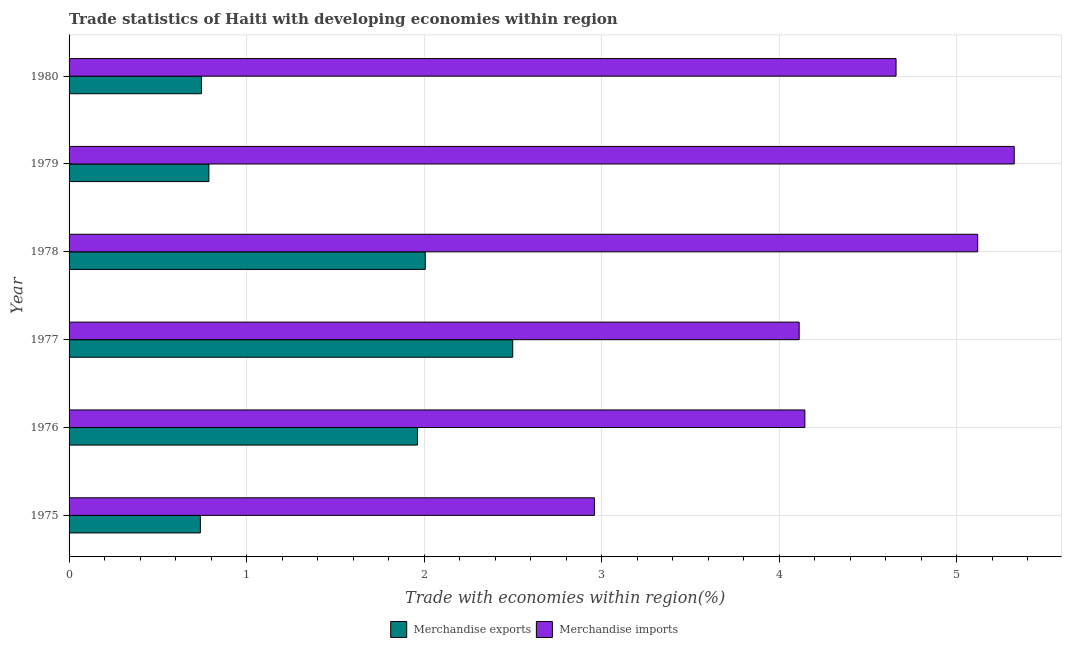How many bars are there on the 6th tick from the top?
Offer a terse response. 2. How many bars are there on the 5th tick from the bottom?
Ensure brevity in your answer.  2. What is the merchandise exports in 1975?
Offer a terse response. 0.74. Across all years, what is the maximum merchandise exports?
Give a very brief answer. 2.5. Across all years, what is the minimum merchandise exports?
Offer a terse response. 0.74. In which year was the merchandise imports maximum?
Give a very brief answer. 1979. In which year was the merchandise exports minimum?
Give a very brief answer. 1975. What is the total merchandise exports in the graph?
Provide a succinct answer. 8.74. What is the difference between the merchandise exports in 1976 and that in 1977?
Ensure brevity in your answer.  -0.54. What is the difference between the merchandise exports in 1979 and the merchandise imports in 1977?
Offer a terse response. -3.32. What is the average merchandise imports per year?
Offer a very short reply. 4.38. In the year 1977, what is the difference between the merchandise exports and merchandise imports?
Your response must be concise. -1.61. In how many years, is the merchandise imports greater than 1.6 %?
Your response must be concise. 6. What is the ratio of the merchandise imports in 1976 to that in 1978?
Offer a very short reply. 0.81. Is the difference between the merchandise exports in 1975 and 1976 greater than the difference between the merchandise imports in 1975 and 1976?
Your answer should be very brief. No. What is the difference between the highest and the second highest merchandise imports?
Ensure brevity in your answer.  0.21. What is the difference between the highest and the lowest merchandise imports?
Offer a very short reply. 2.36. Is the sum of the merchandise exports in 1976 and 1977 greater than the maximum merchandise imports across all years?
Give a very brief answer. No. What does the 1st bar from the bottom in 1975 represents?
Ensure brevity in your answer.  Merchandise exports. How many bars are there?
Provide a succinct answer. 12. Are all the bars in the graph horizontal?
Your answer should be very brief. Yes. What is the difference between two consecutive major ticks on the X-axis?
Provide a short and direct response. 1. Are the values on the major ticks of X-axis written in scientific E-notation?
Offer a very short reply. No. Does the graph contain any zero values?
Give a very brief answer. No. How many legend labels are there?
Provide a succinct answer. 2. How are the legend labels stacked?
Offer a very short reply. Horizontal. What is the title of the graph?
Make the answer very short. Trade statistics of Haiti with developing economies within region. Does "Under five" appear as one of the legend labels in the graph?
Make the answer very short. No. What is the label or title of the X-axis?
Offer a terse response. Trade with economies within region(%). What is the label or title of the Y-axis?
Your answer should be very brief. Year. What is the Trade with economies within region(%) in Merchandise exports in 1975?
Provide a short and direct response. 0.74. What is the Trade with economies within region(%) of Merchandise imports in 1975?
Offer a terse response. 2.96. What is the Trade with economies within region(%) of Merchandise exports in 1976?
Offer a very short reply. 1.96. What is the Trade with economies within region(%) in Merchandise imports in 1976?
Your answer should be compact. 4.14. What is the Trade with economies within region(%) in Merchandise exports in 1977?
Make the answer very short. 2.5. What is the Trade with economies within region(%) of Merchandise imports in 1977?
Offer a very short reply. 4.11. What is the Trade with economies within region(%) of Merchandise exports in 1978?
Your answer should be compact. 2.01. What is the Trade with economies within region(%) of Merchandise imports in 1978?
Provide a short and direct response. 5.12. What is the Trade with economies within region(%) of Merchandise exports in 1979?
Make the answer very short. 0.79. What is the Trade with economies within region(%) in Merchandise imports in 1979?
Ensure brevity in your answer.  5.32. What is the Trade with economies within region(%) of Merchandise exports in 1980?
Your answer should be compact. 0.75. What is the Trade with economies within region(%) in Merchandise imports in 1980?
Ensure brevity in your answer.  4.66. Across all years, what is the maximum Trade with economies within region(%) in Merchandise exports?
Ensure brevity in your answer.  2.5. Across all years, what is the maximum Trade with economies within region(%) in Merchandise imports?
Ensure brevity in your answer.  5.32. Across all years, what is the minimum Trade with economies within region(%) of Merchandise exports?
Offer a very short reply. 0.74. Across all years, what is the minimum Trade with economies within region(%) of Merchandise imports?
Ensure brevity in your answer.  2.96. What is the total Trade with economies within region(%) in Merchandise exports in the graph?
Provide a short and direct response. 8.74. What is the total Trade with economies within region(%) of Merchandise imports in the graph?
Offer a very short reply. 26.31. What is the difference between the Trade with economies within region(%) of Merchandise exports in 1975 and that in 1976?
Ensure brevity in your answer.  -1.22. What is the difference between the Trade with economies within region(%) of Merchandise imports in 1975 and that in 1976?
Ensure brevity in your answer.  -1.19. What is the difference between the Trade with economies within region(%) in Merchandise exports in 1975 and that in 1977?
Your answer should be very brief. -1.76. What is the difference between the Trade with economies within region(%) in Merchandise imports in 1975 and that in 1977?
Ensure brevity in your answer.  -1.15. What is the difference between the Trade with economies within region(%) in Merchandise exports in 1975 and that in 1978?
Your response must be concise. -1.27. What is the difference between the Trade with economies within region(%) of Merchandise imports in 1975 and that in 1978?
Make the answer very short. -2.16. What is the difference between the Trade with economies within region(%) in Merchandise exports in 1975 and that in 1979?
Keep it short and to the point. -0.05. What is the difference between the Trade with economies within region(%) of Merchandise imports in 1975 and that in 1979?
Make the answer very short. -2.36. What is the difference between the Trade with economies within region(%) in Merchandise exports in 1975 and that in 1980?
Keep it short and to the point. -0.01. What is the difference between the Trade with economies within region(%) of Merchandise imports in 1975 and that in 1980?
Offer a very short reply. -1.7. What is the difference between the Trade with economies within region(%) of Merchandise exports in 1976 and that in 1977?
Provide a succinct answer. -0.54. What is the difference between the Trade with economies within region(%) of Merchandise imports in 1976 and that in 1977?
Offer a terse response. 0.03. What is the difference between the Trade with economies within region(%) in Merchandise exports in 1976 and that in 1978?
Offer a very short reply. -0.04. What is the difference between the Trade with economies within region(%) in Merchandise imports in 1976 and that in 1978?
Your response must be concise. -0.97. What is the difference between the Trade with economies within region(%) of Merchandise exports in 1976 and that in 1979?
Offer a terse response. 1.17. What is the difference between the Trade with economies within region(%) of Merchandise imports in 1976 and that in 1979?
Your answer should be very brief. -1.18. What is the difference between the Trade with economies within region(%) of Merchandise exports in 1976 and that in 1980?
Offer a very short reply. 1.22. What is the difference between the Trade with economies within region(%) of Merchandise imports in 1976 and that in 1980?
Your answer should be very brief. -0.51. What is the difference between the Trade with economies within region(%) in Merchandise exports in 1977 and that in 1978?
Your answer should be very brief. 0.49. What is the difference between the Trade with economies within region(%) in Merchandise imports in 1977 and that in 1978?
Your response must be concise. -1.01. What is the difference between the Trade with economies within region(%) of Merchandise exports in 1977 and that in 1979?
Your answer should be very brief. 1.71. What is the difference between the Trade with economies within region(%) of Merchandise imports in 1977 and that in 1979?
Provide a short and direct response. -1.21. What is the difference between the Trade with economies within region(%) in Merchandise exports in 1977 and that in 1980?
Provide a succinct answer. 1.75. What is the difference between the Trade with economies within region(%) of Merchandise imports in 1977 and that in 1980?
Your answer should be compact. -0.55. What is the difference between the Trade with economies within region(%) of Merchandise exports in 1978 and that in 1979?
Make the answer very short. 1.22. What is the difference between the Trade with economies within region(%) of Merchandise imports in 1978 and that in 1979?
Offer a very short reply. -0.21. What is the difference between the Trade with economies within region(%) of Merchandise exports in 1978 and that in 1980?
Offer a very short reply. 1.26. What is the difference between the Trade with economies within region(%) in Merchandise imports in 1978 and that in 1980?
Make the answer very short. 0.46. What is the difference between the Trade with economies within region(%) in Merchandise exports in 1979 and that in 1980?
Ensure brevity in your answer.  0.04. What is the difference between the Trade with economies within region(%) in Merchandise imports in 1979 and that in 1980?
Provide a succinct answer. 0.67. What is the difference between the Trade with economies within region(%) of Merchandise exports in 1975 and the Trade with economies within region(%) of Merchandise imports in 1976?
Your response must be concise. -3.4. What is the difference between the Trade with economies within region(%) in Merchandise exports in 1975 and the Trade with economies within region(%) in Merchandise imports in 1977?
Give a very brief answer. -3.37. What is the difference between the Trade with economies within region(%) in Merchandise exports in 1975 and the Trade with economies within region(%) in Merchandise imports in 1978?
Ensure brevity in your answer.  -4.38. What is the difference between the Trade with economies within region(%) of Merchandise exports in 1975 and the Trade with economies within region(%) of Merchandise imports in 1979?
Offer a very short reply. -4.58. What is the difference between the Trade with economies within region(%) in Merchandise exports in 1975 and the Trade with economies within region(%) in Merchandise imports in 1980?
Offer a terse response. -3.92. What is the difference between the Trade with economies within region(%) of Merchandise exports in 1976 and the Trade with economies within region(%) of Merchandise imports in 1977?
Provide a succinct answer. -2.15. What is the difference between the Trade with economies within region(%) of Merchandise exports in 1976 and the Trade with economies within region(%) of Merchandise imports in 1978?
Provide a succinct answer. -3.15. What is the difference between the Trade with economies within region(%) in Merchandise exports in 1976 and the Trade with economies within region(%) in Merchandise imports in 1979?
Make the answer very short. -3.36. What is the difference between the Trade with economies within region(%) in Merchandise exports in 1976 and the Trade with economies within region(%) in Merchandise imports in 1980?
Your answer should be very brief. -2.7. What is the difference between the Trade with economies within region(%) of Merchandise exports in 1977 and the Trade with economies within region(%) of Merchandise imports in 1978?
Your response must be concise. -2.62. What is the difference between the Trade with economies within region(%) of Merchandise exports in 1977 and the Trade with economies within region(%) of Merchandise imports in 1979?
Provide a succinct answer. -2.82. What is the difference between the Trade with economies within region(%) of Merchandise exports in 1977 and the Trade with economies within region(%) of Merchandise imports in 1980?
Offer a very short reply. -2.16. What is the difference between the Trade with economies within region(%) of Merchandise exports in 1978 and the Trade with economies within region(%) of Merchandise imports in 1979?
Provide a succinct answer. -3.32. What is the difference between the Trade with economies within region(%) of Merchandise exports in 1978 and the Trade with economies within region(%) of Merchandise imports in 1980?
Provide a short and direct response. -2.65. What is the difference between the Trade with economies within region(%) of Merchandise exports in 1979 and the Trade with economies within region(%) of Merchandise imports in 1980?
Offer a terse response. -3.87. What is the average Trade with economies within region(%) of Merchandise exports per year?
Keep it short and to the point. 1.46. What is the average Trade with economies within region(%) of Merchandise imports per year?
Your answer should be very brief. 4.39. In the year 1975, what is the difference between the Trade with economies within region(%) of Merchandise exports and Trade with economies within region(%) of Merchandise imports?
Offer a very short reply. -2.22. In the year 1976, what is the difference between the Trade with economies within region(%) in Merchandise exports and Trade with economies within region(%) in Merchandise imports?
Provide a succinct answer. -2.18. In the year 1977, what is the difference between the Trade with economies within region(%) of Merchandise exports and Trade with economies within region(%) of Merchandise imports?
Offer a very short reply. -1.61. In the year 1978, what is the difference between the Trade with economies within region(%) in Merchandise exports and Trade with economies within region(%) in Merchandise imports?
Your answer should be compact. -3.11. In the year 1979, what is the difference between the Trade with economies within region(%) of Merchandise exports and Trade with economies within region(%) of Merchandise imports?
Your answer should be very brief. -4.54. In the year 1980, what is the difference between the Trade with economies within region(%) in Merchandise exports and Trade with economies within region(%) in Merchandise imports?
Offer a terse response. -3.91. What is the ratio of the Trade with economies within region(%) in Merchandise exports in 1975 to that in 1976?
Give a very brief answer. 0.38. What is the ratio of the Trade with economies within region(%) of Merchandise imports in 1975 to that in 1976?
Keep it short and to the point. 0.71. What is the ratio of the Trade with economies within region(%) in Merchandise exports in 1975 to that in 1977?
Your response must be concise. 0.3. What is the ratio of the Trade with economies within region(%) in Merchandise imports in 1975 to that in 1977?
Keep it short and to the point. 0.72. What is the ratio of the Trade with economies within region(%) of Merchandise exports in 1975 to that in 1978?
Your answer should be very brief. 0.37. What is the ratio of the Trade with economies within region(%) of Merchandise imports in 1975 to that in 1978?
Give a very brief answer. 0.58. What is the ratio of the Trade with economies within region(%) of Merchandise exports in 1975 to that in 1979?
Your answer should be very brief. 0.94. What is the ratio of the Trade with economies within region(%) in Merchandise imports in 1975 to that in 1979?
Offer a terse response. 0.56. What is the ratio of the Trade with economies within region(%) of Merchandise exports in 1975 to that in 1980?
Provide a succinct answer. 0.99. What is the ratio of the Trade with economies within region(%) of Merchandise imports in 1975 to that in 1980?
Ensure brevity in your answer.  0.64. What is the ratio of the Trade with economies within region(%) in Merchandise exports in 1976 to that in 1977?
Offer a terse response. 0.79. What is the ratio of the Trade with economies within region(%) of Merchandise exports in 1976 to that in 1978?
Offer a terse response. 0.98. What is the ratio of the Trade with economies within region(%) in Merchandise imports in 1976 to that in 1978?
Your answer should be very brief. 0.81. What is the ratio of the Trade with economies within region(%) in Merchandise exports in 1976 to that in 1979?
Your response must be concise. 2.49. What is the ratio of the Trade with economies within region(%) of Merchandise imports in 1976 to that in 1979?
Offer a terse response. 0.78. What is the ratio of the Trade with economies within region(%) in Merchandise exports in 1976 to that in 1980?
Make the answer very short. 2.63. What is the ratio of the Trade with economies within region(%) in Merchandise imports in 1976 to that in 1980?
Keep it short and to the point. 0.89. What is the ratio of the Trade with economies within region(%) of Merchandise exports in 1977 to that in 1978?
Provide a short and direct response. 1.25. What is the ratio of the Trade with economies within region(%) of Merchandise imports in 1977 to that in 1978?
Your answer should be very brief. 0.8. What is the ratio of the Trade with economies within region(%) in Merchandise exports in 1977 to that in 1979?
Your answer should be very brief. 3.17. What is the ratio of the Trade with economies within region(%) in Merchandise imports in 1977 to that in 1979?
Your response must be concise. 0.77. What is the ratio of the Trade with economies within region(%) of Merchandise exports in 1977 to that in 1980?
Give a very brief answer. 3.35. What is the ratio of the Trade with economies within region(%) in Merchandise imports in 1977 to that in 1980?
Your response must be concise. 0.88. What is the ratio of the Trade with economies within region(%) in Merchandise exports in 1978 to that in 1979?
Give a very brief answer. 2.55. What is the ratio of the Trade with economies within region(%) in Merchandise imports in 1978 to that in 1979?
Your response must be concise. 0.96. What is the ratio of the Trade with economies within region(%) in Merchandise exports in 1978 to that in 1980?
Keep it short and to the point. 2.69. What is the ratio of the Trade with economies within region(%) of Merchandise imports in 1978 to that in 1980?
Provide a succinct answer. 1.1. What is the ratio of the Trade with economies within region(%) of Merchandise exports in 1979 to that in 1980?
Ensure brevity in your answer.  1.06. What is the difference between the highest and the second highest Trade with economies within region(%) of Merchandise exports?
Make the answer very short. 0.49. What is the difference between the highest and the second highest Trade with economies within region(%) in Merchandise imports?
Your answer should be very brief. 0.21. What is the difference between the highest and the lowest Trade with economies within region(%) of Merchandise exports?
Provide a succinct answer. 1.76. What is the difference between the highest and the lowest Trade with economies within region(%) of Merchandise imports?
Offer a terse response. 2.36. 